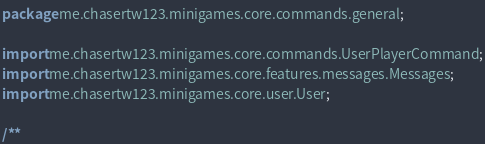Convert code to text. <code><loc_0><loc_0><loc_500><loc_500><_Java_>package me.chasertw123.minigames.core.commands.general;

import me.chasertw123.minigames.core.commands.UserPlayerCommand;
import me.chasertw123.minigames.core.features.messages.Messages;
import me.chasertw123.minigames.core.user.User;

/**</code> 